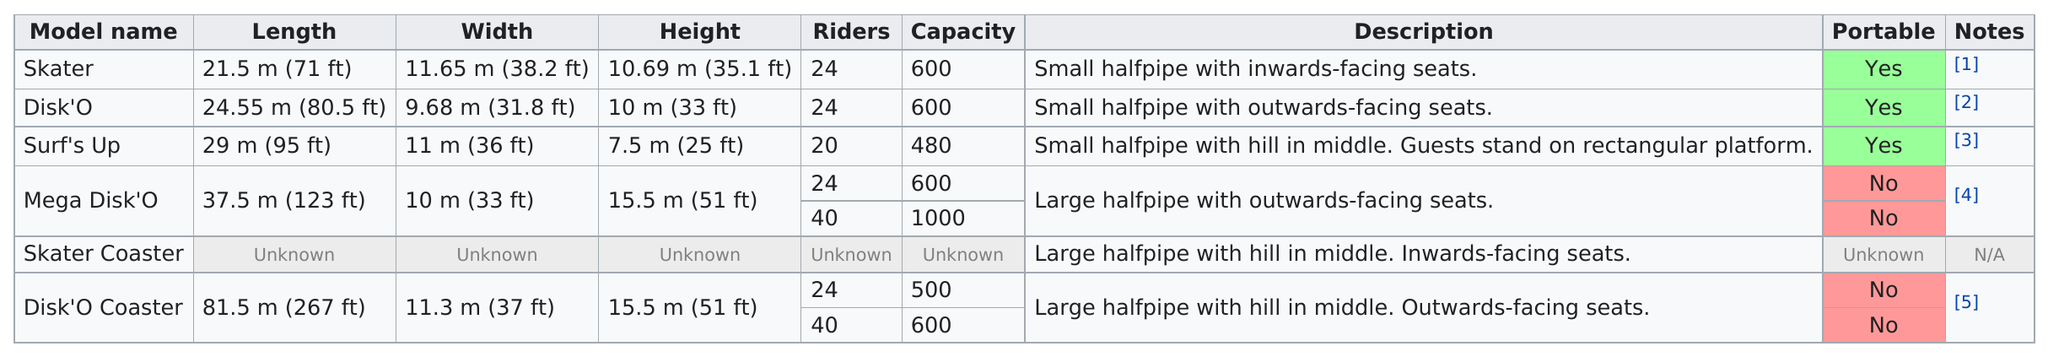Specify some key components in this picture. The skater model includes 24 riders. The skater is the smallest ride. There are 3 portable rides. The total number of models created is 6. Out of the total number of rides, how many have a maximum capacity of 600 and are operated between 3 and...? 